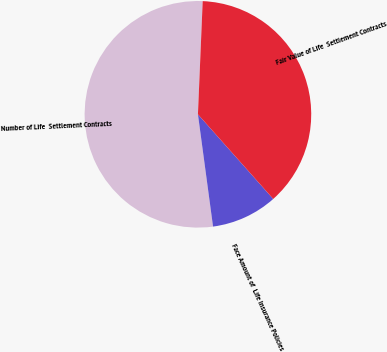Convert chart. <chart><loc_0><loc_0><loc_500><loc_500><pie_chart><fcel>Number of Life  Settlement Contracts<fcel>Face Amount of  Life Insurance Policies<fcel>Fair Value of Life  Settlement Contracts<nl><fcel>52.8%<fcel>9.44%<fcel>37.76%<nl></chart> 